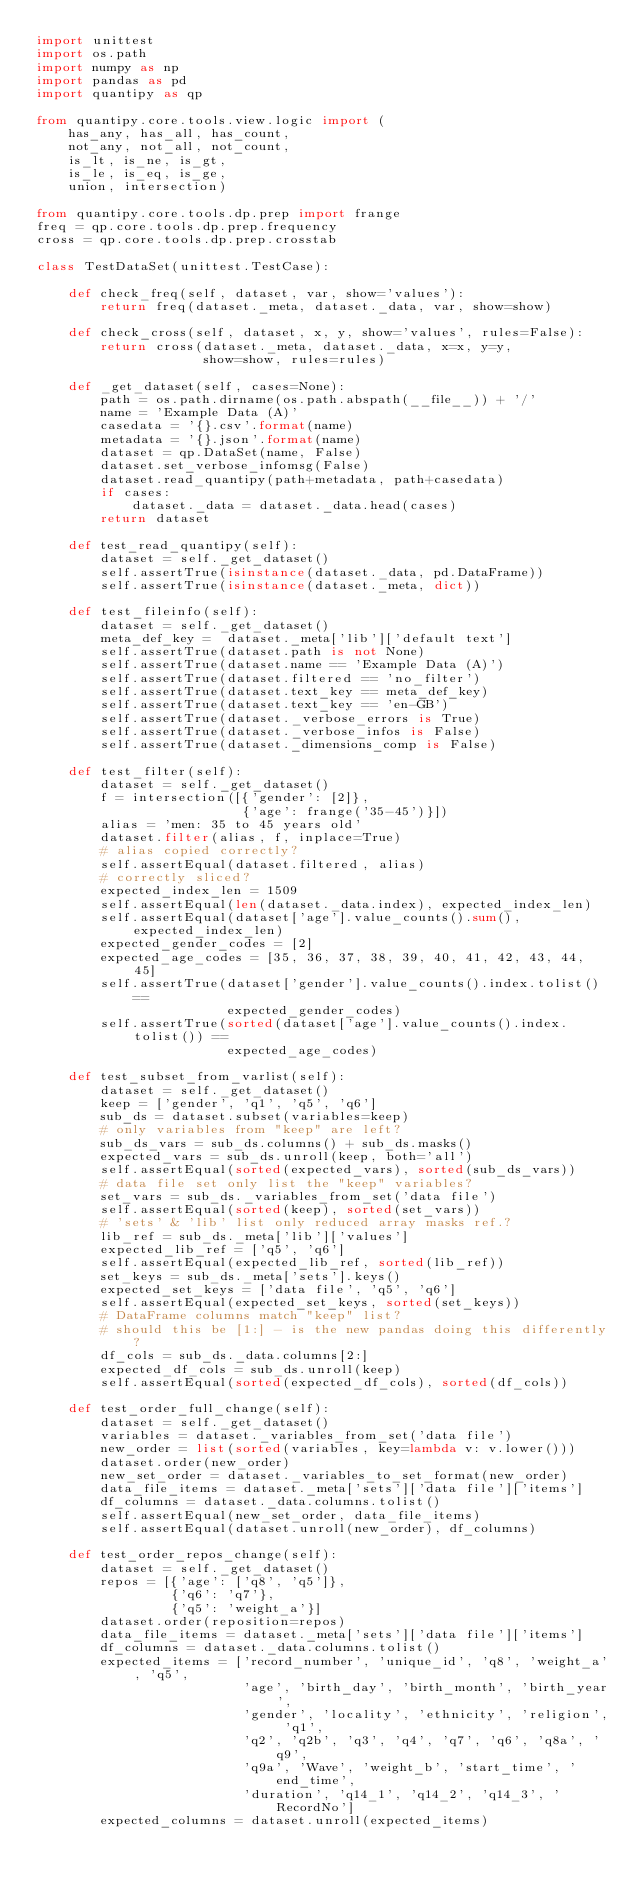<code> <loc_0><loc_0><loc_500><loc_500><_Python_>import unittest
import os.path
import numpy as np
import pandas as pd
import quantipy as qp

from quantipy.core.tools.view.logic import (
    has_any, has_all, has_count,
    not_any, not_all, not_count,
    is_lt, is_ne, is_gt,
    is_le, is_eq, is_ge,
    union, intersection)

from quantipy.core.tools.dp.prep import frange
freq = qp.core.tools.dp.prep.frequency
cross = qp.core.tools.dp.prep.crosstab

class TestDataSet(unittest.TestCase):

    def check_freq(self, dataset, var, show='values'):
        return freq(dataset._meta, dataset._data, var, show=show)

    def check_cross(self, dataset, x, y, show='values', rules=False):
        return cross(dataset._meta, dataset._data, x=x, y=y,
                     show=show, rules=rules)

    def _get_dataset(self, cases=None):
        path = os.path.dirname(os.path.abspath(__file__)) + '/'
        name = 'Example Data (A)'
        casedata = '{}.csv'.format(name)
        metadata = '{}.json'.format(name)
        dataset = qp.DataSet(name, False)
        dataset.set_verbose_infomsg(False)
        dataset.read_quantipy(path+metadata, path+casedata)
        if cases:
            dataset._data = dataset._data.head(cases)
        return dataset

    def test_read_quantipy(self):
        dataset = self._get_dataset()
        self.assertTrue(isinstance(dataset._data, pd.DataFrame))
        self.assertTrue(isinstance(dataset._meta, dict))

    def test_fileinfo(self):
        dataset = self._get_dataset()
        meta_def_key =  dataset._meta['lib']['default text']
        self.assertTrue(dataset.path is not None)
        self.assertTrue(dataset.name == 'Example Data (A)')
        self.assertTrue(dataset.filtered == 'no_filter')
        self.assertTrue(dataset.text_key == meta_def_key)
        self.assertTrue(dataset.text_key == 'en-GB')
        self.assertTrue(dataset._verbose_errors is True)
        self.assertTrue(dataset._verbose_infos is False)
        self.assertTrue(dataset._dimensions_comp is False)

    def test_filter(self):
        dataset = self._get_dataset()
        f = intersection([{'gender': [2]},
                          {'age': frange('35-45')}])
        alias = 'men: 35 to 45 years old'
        dataset.filter(alias, f, inplace=True)
        # alias copied correctly?
        self.assertEqual(dataset.filtered, alias)
        # correctly sliced?
        expected_index_len = 1509
        self.assertEqual(len(dataset._data.index), expected_index_len)
        self.assertEqual(dataset['age'].value_counts().sum(), expected_index_len)
        expected_gender_codes = [2]
        expected_age_codes = [35, 36, 37, 38, 39, 40, 41, 42, 43, 44, 45]
        self.assertTrue(dataset['gender'].value_counts().index.tolist() ==
                        expected_gender_codes)
        self.assertTrue(sorted(dataset['age'].value_counts().index.tolist()) ==
                        expected_age_codes)

    def test_subset_from_varlist(self):
        dataset = self._get_dataset()
        keep = ['gender', 'q1', 'q5', 'q6']
        sub_ds = dataset.subset(variables=keep)
        # only variables from "keep" are left?
        sub_ds_vars = sub_ds.columns() + sub_ds.masks()
        expected_vars = sub_ds.unroll(keep, both='all')
        self.assertEqual(sorted(expected_vars), sorted(sub_ds_vars))
        # data file set only list the "keep" variables?
        set_vars = sub_ds._variables_from_set('data file')
        self.assertEqual(sorted(keep), sorted(set_vars))
        # 'sets' & 'lib' list only reduced array masks ref.?
        lib_ref = sub_ds._meta['lib']['values']
        expected_lib_ref = ['q5', 'q6']
        self.assertEqual(expected_lib_ref, sorted(lib_ref))
        set_keys = sub_ds._meta['sets'].keys()
        expected_set_keys = ['data file', 'q5', 'q6']
        self.assertEqual(expected_set_keys, sorted(set_keys))
        # DataFrame columns match "keep" list?
        # should this be [1:] - is the new pandas doing this differently?
        df_cols = sub_ds._data.columns[2:]
        expected_df_cols = sub_ds.unroll(keep)
        self.assertEqual(sorted(expected_df_cols), sorted(df_cols))

    def test_order_full_change(self):
        dataset = self._get_dataset()
        variables = dataset._variables_from_set('data file')
        new_order = list(sorted(variables, key=lambda v: v.lower()))
        dataset.order(new_order)
        new_set_order = dataset._variables_to_set_format(new_order)
        data_file_items = dataset._meta['sets']['data file']['items']
        df_columns = dataset._data.columns.tolist()
        self.assertEqual(new_set_order, data_file_items)
        self.assertEqual(dataset.unroll(new_order), df_columns)

    def test_order_repos_change(self):
        dataset = self._get_dataset()
        repos = [{'age': ['q8', 'q5']},
                 {'q6': 'q7'},
                 {'q5': 'weight_a'}]
        dataset.order(reposition=repos)
        data_file_items = dataset._meta['sets']['data file']['items']
        df_columns = dataset._data.columns.tolist()
        expected_items = ['record_number', 'unique_id', 'q8', 'weight_a', 'q5',
                          'age', 'birth_day', 'birth_month', 'birth_year',
                          'gender', 'locality', 'ethnicity', 'religion', 'q1',
                          'q2', 'q2b', 'q3', 'q4', 'q7', 'q6', 'q8a', 'q9',
                          'q9a', 'Wave', 'weight_b', 'start_time', 'end_time',
                          'duration', 'q14_1', 'q14_2', 'q14_3', 'RecordNo']
        expected_columns = dataset.unroll(expected_items)</code> 